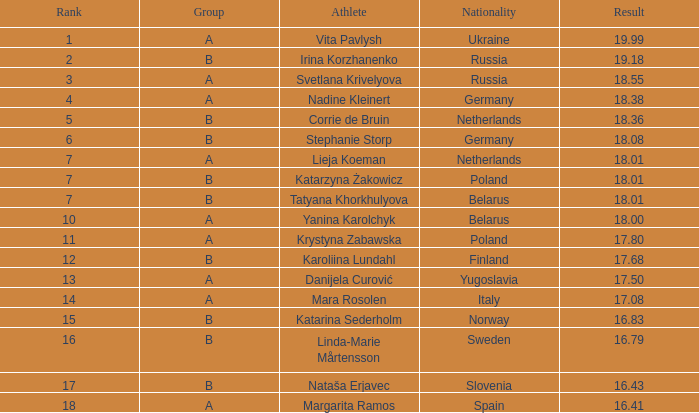Which athlete, has an 18.55 result Svetlana Krivelyova. 